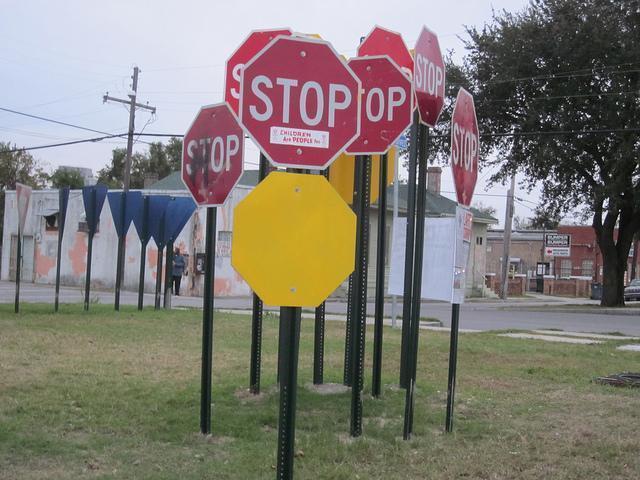What is the purpose of this signage?
Pick the right solution, then justify: 'Answer: answer
Rationale: rationale.'
Options: Multiple stoppages, destruction, lightning rods, art display. Answer: art display.
Rationale: It is not in the middle of a road, and too many stop signs together would create chaos, so it is assumed this is for art. 